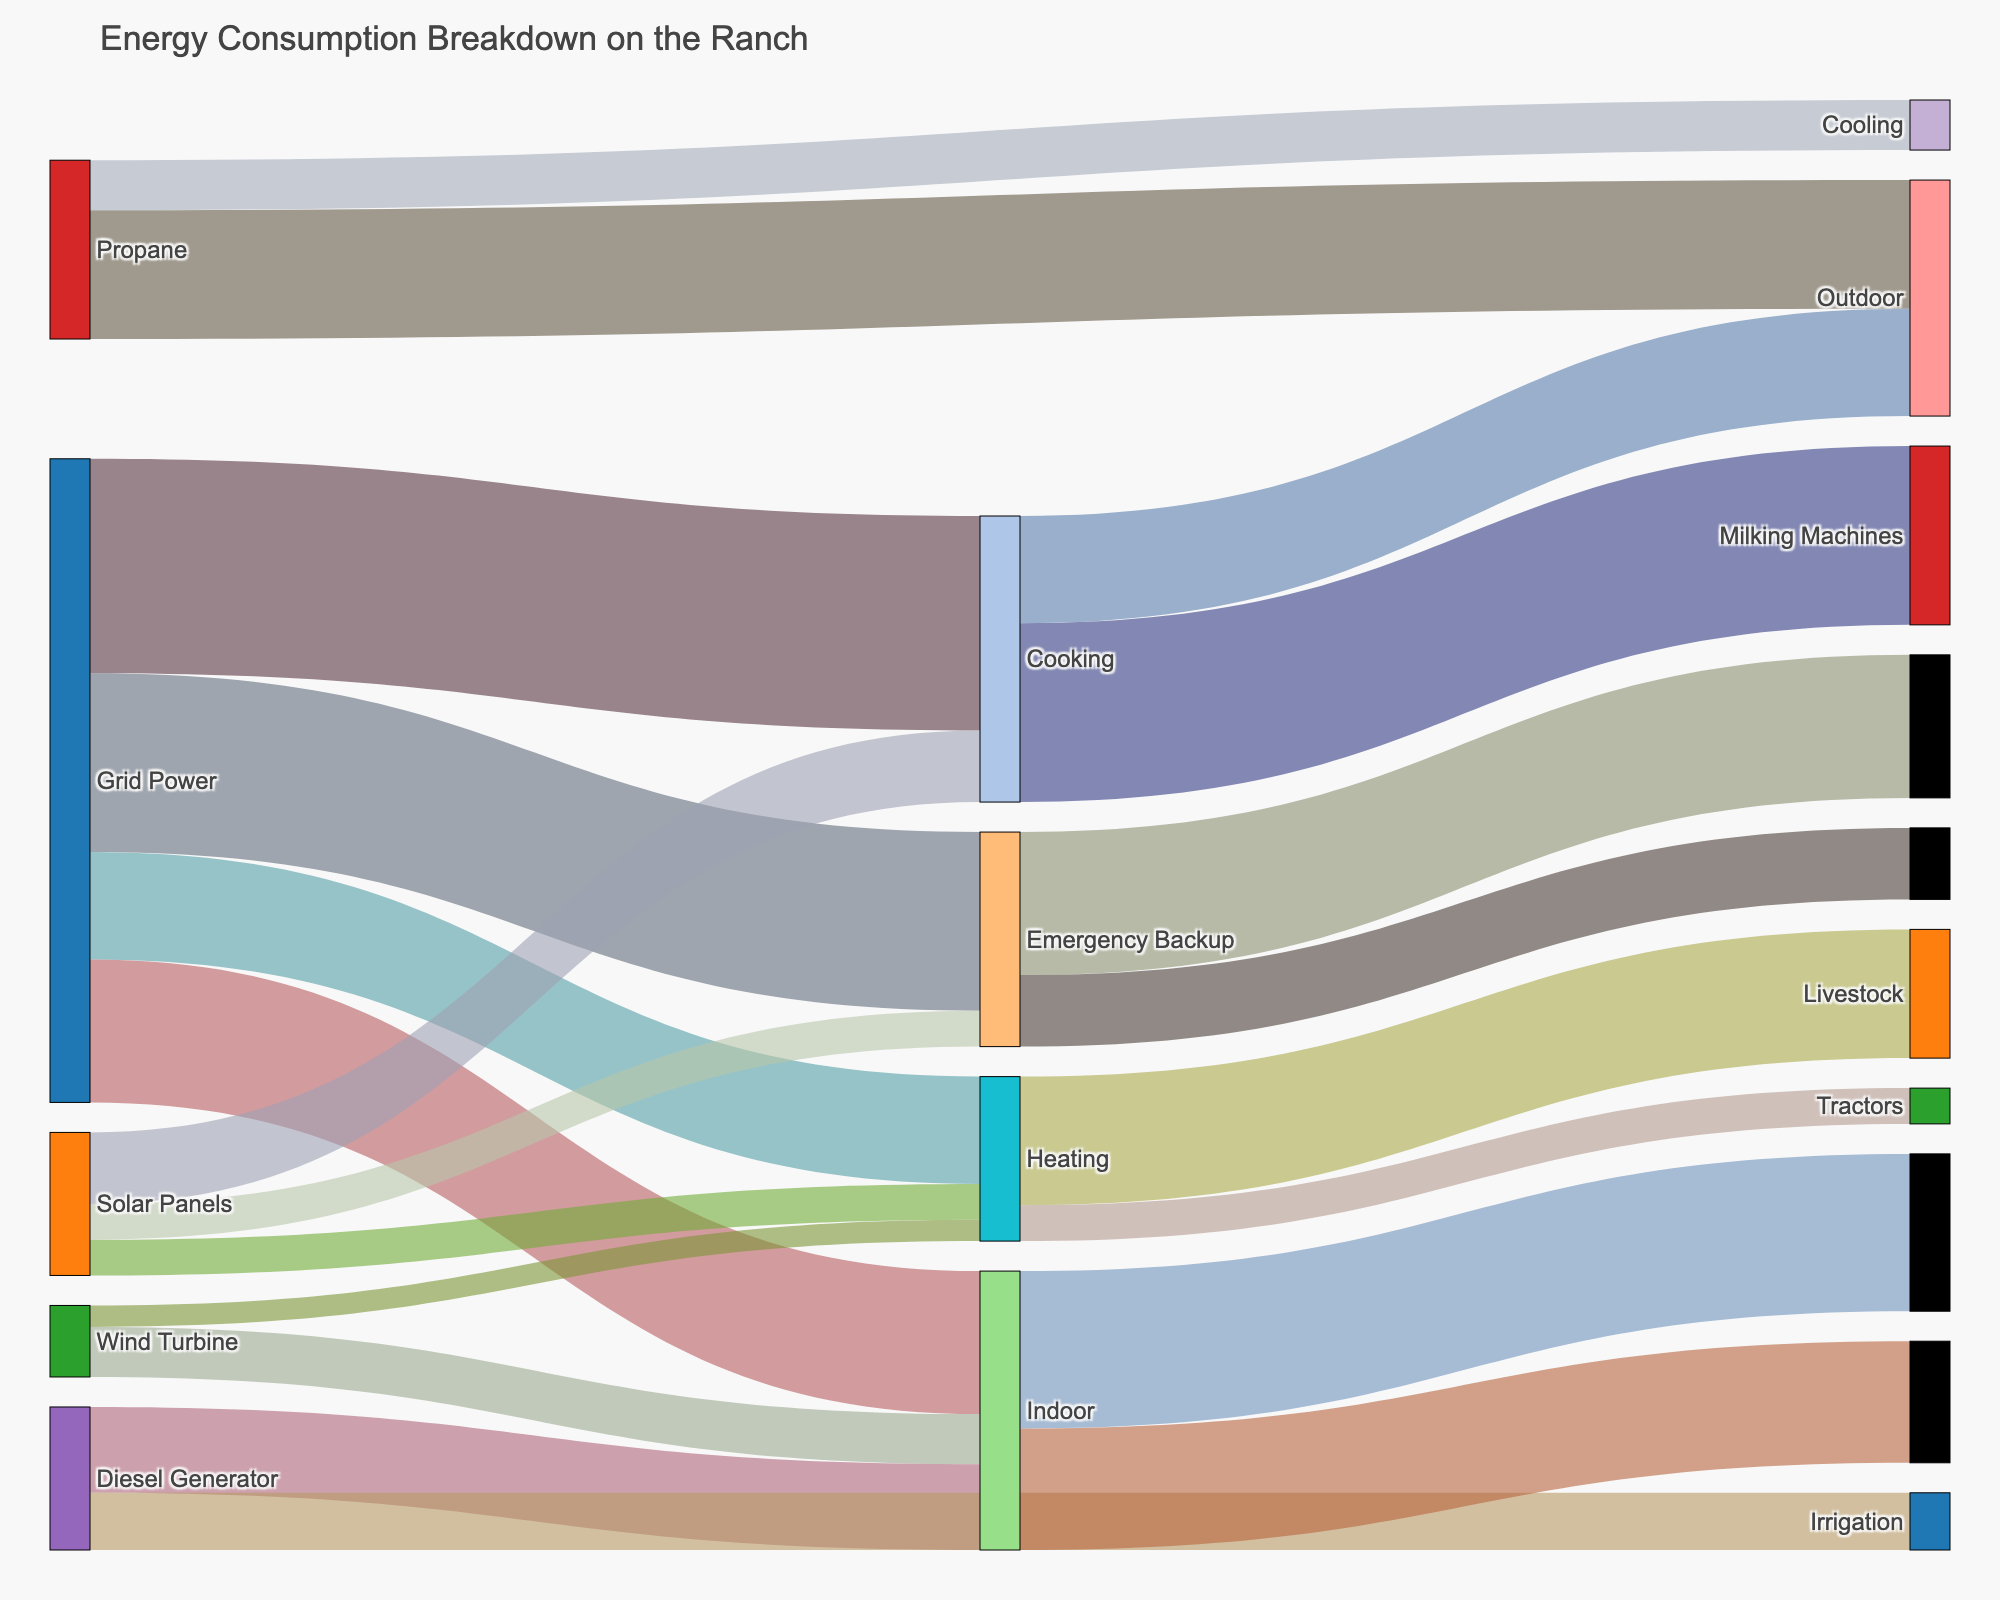How much power does the Grid distribute in total? Sum up the values the Grid Power source sends to different targets: Lighting (15) + HVAC (30) + Water Pumps (25) + Farm Equipment (20).
Answer: 90 Which source provides the most energy for HVAC? Compare the values each source provides for HVAC: Grid Power (30), Solar Panels (10). Grid Power provides more.
Answer: Grid Power What is the total energy used for heating purposes? Add the values for HVAC Heating (15) and Propane Heating (18).
Answer: 33 Is more energy used for Lighting or Water Pumps? Compare the total values for Lighting (from all sources) and Water Pumps (from all sources). Lighting total: Grid Power (15) + Solar Panels (5) + Wind Turbine (3) = 23. Water Pumps total: Grid Power (25) + Solar Panels (5) = 30. Water Pumps uses more energy.
Answer: Water Pumps What is the total contribution of Solar Panels to the ranch's energy consumption? Sum the values the Solar Panels provide to different targets: Lighting (5) + HVAC (10) + Water Pumps (5).
Answer: 20 Which source has the least diverse distribution across different targets? Identify the source with energy directed to the fewest different targets. Wind Turbine is used for Lighting and Farm Equipment only, making it the least diverse.
Answer: Wind Turbine Between Farm Equipment and HVAC, which has the higher total energy consumption? Calculate the sum of values for Farm Equipment and HVAC from all sources. Farm Equipment: Grid Power (20) + Wind Turbine (7) + Diesel Generator (12) = 39. HVAC: Grid Power (30) + Solar Panels (10) = 40. HVAC has higher usage.
Answer: HVAC If lighting is broken down into Indoor and Outdoor, which consumes more energy? Lighting Indoor has a value of 18, and Lighting Outdoor has a value of 5. Indoor consumes more energy.
Answer: Indoor What is the primary source of energy for Propane? Identify the target that receives the highest energy value from Propane: Heating (18) compared to Cooking (7).
Answer: Heating 